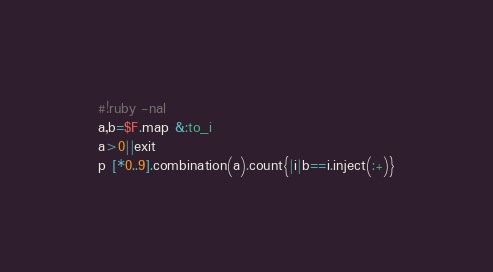<code> <loc_0><loc_0><loc_500><loc_500><_Ruby_>#!ruby -nal
a,b=$F.map &:to_i
a>0||exit
p [*0..9].combination(a).count{|i|b==i.inject(:+)}</code> 